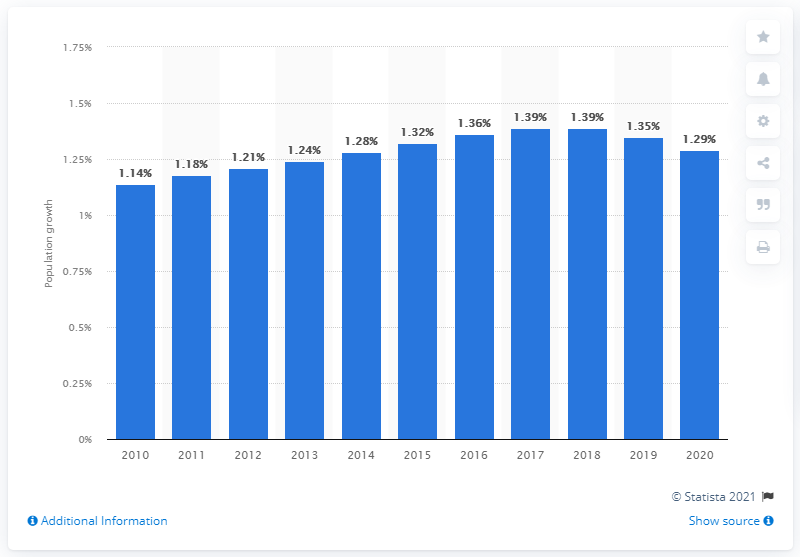Identify some key points in this picture. According to the latest estimates, Iran's population grew by 1.29% in 2020. 